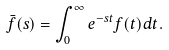Convert formula to latex. <formula><loc_0><loc_0><loc_500><loc_500>\bar { f } ( s ) = \int _ { 0 } ^ { \infty } e ^ { - s t } f ( t ) d t .</formula> 